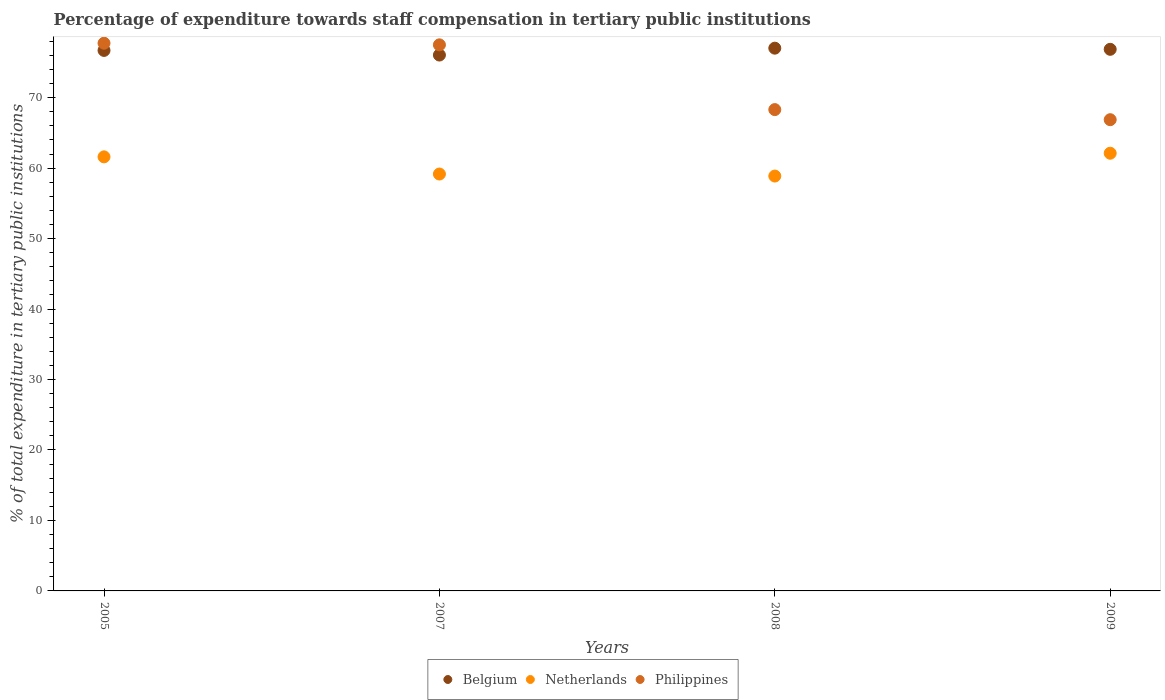How many different coloured dotlines are there?
Make the answer very short. 3. What is the percentage of expenditure towards staff compensation in Philippines in 2009?
Ensure brevity in your answer.  66.88. Across all years, what is the maximum percentage of expenditure towards staff compensation in Philippines?
Your answer should be very brief. 77.73. Across all years, what is the minimum percentage of expenditure towards staff compensation in Philippines?
Give a very brief answer. 66.88. What is the total percentage of expenditure towards staff compensation in Philippines in the graph?
Make the answer very short. 290.41. What is the difference between the percentage of expenditure towards staff compensation in Philippines in 2007 and that in 2008?
Give a very brief answer. 9.19. What is the difference between the percentage of expenditure towards staff compensation in Philippines in 2008 and the percentage of expenditure towards staff compensation in Belgium in 2007?
Your response must be concise. -7.74. What is the average percentage of expenditure towards staff compensation in Belgium per year?
Your answer should be compact. 76.66. In the year 2005, what is the difference between the percentage of expenditure towards staff compensation in Netherlands and percentage of expenditure towards staff compensation in Belgium?
Your response must be concise. -15.1. What is the ratio of the percentage of expenditure towards staff compensation in Philippines in 2008 to that in 2009?
Provide a short and direct response. 1.02. Is the percentage of expenditure towards staff compensation in Belgium in 2005 less than that in 2009?
Your response must be concise. Yes. What is the difference between the highest and the second highest percentage of expenditure towards staff compensation in Netherlands?
Make the answer very short. 0.51. What is the difference between the highest and the lowest percentage of expenditure towards staff compensation in Netherlands?
Keep it short and to the point. 3.24. In how many years, is the percentage of expenditure towards staff compensation in Philippines greater than the average percentage of expenditure towards staff compensation in Philippines taken over all years?
Your answer should be very brief. 2. Is the sum of the percentage of expenditure towards staff compensation in Belgium in 2008 and 2009 greater than the maximum percentage of expenditure towards staff compensation in Philippines across all years?
Keep it short and to the point. Yes. Is it the case that in every year, the sum of the percentage of expenditure towards staff compensation in Netherlands and percentage of expenditure towards staff compensation in Philippines  is greater than the percentage of expenditure towards staff compensation in Belgium?
Your answer should be very brief. Yes. Is the percentage of expenditure towards staff compensation in Belgium strictly less than the percentage of expenditure towards staff compensation in Netherlands over the years?
Your response must be concise. No. How many years are there in the graph?
Provide a short and direct response. 4. Are the values on the major ticks of Y-axis written in scientific E-notation?
Keep it short and to the point. No. Where does the legend appear in the graph?
Offer a very short reply. Bottom center. How are the legend labels stacked?
Offer a very short reply. Horizontal. What is the title of the graph?
Give a very brief answer. Percentage of expenditure towards staff compensation in tertiary public institutions. What is the label or title of the X-axis?
Offer a very short reply. Years. What is the label or title of the Y-axis?
Offer a very short reply. % of total expenditure in tertiary public institutions. What is the % of total expenditure in tertiary public institutions of Belgium in 2005?
Make the answer very short. 76.71. What is the % of total expenditure in tertiary public institutions of Netherlands in 2005?
Ensure brevity in your answer.  61.6. What is the % of total expenditure in tertiary public institutions of Philippines in 2005?
Offer a terse response. 77.73. What is the % of total expenditure in tertiary public institutions in Belgium in 2007?
Your response must be concise. 76.05. What is the % of total expenditure in tertiary public institutions in Netherlands in 2007?
Your answer should be very brief. 59.17. What is the % of total expenditure in tertiary public institutions in Philippines in 2007?
Your answer should be very brief. 77.5. What is the % of total expenditure in tertiary public institutions of Belgium in 2008?
Offer a very short reply. 77.03. What is the % of total expenditure in tertiary public institutions in Netherlands in 2008?
Your answer should be very brief. 58.88. What is the % of total expenditure in tertiary public institutions in Philippines in 2008?
Your answer should be very brief. 68.31. What is the % of total expenditure in tertiary public institutions of Belgium in 2009?
Your answer should be very brief. 76.86. What is the % of total expenditure in tertiary public institutions of Netherlands in 2009?
Offer a very short reply. 62.12. What is the % of total expenditure in tertiary public institutions in Philippines in 2009?
Provide a succinct answer. 66.88. Across all years, what is the maximum % of total expenditure in tertiary public institutions of Belgium?
Give a very brief answer. 77.03. Across all years, what is the maximum % of total expenditure in tertiary public institutions in Netherlands?
Your response must be concise. 62.12. Across all years, what is the maximum % of total expenditure in tertiary public institutions of Philippines?
Offer a very short reply. 77.73. Across all years, what is the minimum % of total expenditure in tertiary public institutions in Belgium?
Ensure brevity in your answer.  76.05. Across all years, what is the minimum % of total expenditure in tertiary public institutions in Netherlands?
Your response must be concise. 58.88. Across all years, what is the minimum % of total expenditure in tertiary public institutions in Philippines?
Your response must be concise. 66.88. What is the total % of total expenditure in tertiary public institutions in Belgium in the graph?
Make the answer very short. 306.64. What is the total % of total expenditure in tertiary public institutions of Netherlands in the graph?
Keep it short and to the point. 241.76. What is the total % of total expenditure in tertiary public institutions of Philippines in the graph?
Keep it short and to the point. 290.41. What is the difference between the % of total expenditure in tertiary public institutions in Belgium in 2005 and that in 2007?
Your response must be concise. 0.66. What is the difference between the % of total expenditure in tertiary public institutions of Netherlands in 2005 and that in 2007?
Offer a terse response. 2.44. What is the difference between the % of total expenditure in tertiary public institutions in Philippines in 2005 and that in 2007?
Ensure brevity in your answer.  0.23. What is the difference between the % of total expenditure in tertiary public institutions in Belgium in 2005 and that in 2008?
Your response must be concise. -0.32. What is the difference between the % of total expenditure in tertiary public institutions of Netherlands in 2005 and that in 2008?
Keep it short and to the point. 2.73. What is the difference between the % of total expenditure in tertiary public institutions in Philippines in 2005 and that in 2008?
Provide a short and direct response. 9.42. What is the difference between the % of total expenditure in tertiary public institutions in Belgium in 2005 and that in 2009?
Provide a succinct answer. -0.16. What is the difference between the % of total expenditure in tertiary public institutions in Netherlands in 2005 and that in 2009?
Offer a very short reply. -0.51. What is the difference between the % of total expenditure in tertiary public institutions of Philippines in 2005 and that in 2009?
Your response must be concise. 10.85. What is the difference between the % of total expenditure in tertiary public institutions in Belgium in 2007 and that in 2008?
Keep it short and to the point. -0.98. What is the difference between the % of total expenditure in tertiary public institutions of Netherlands in 2007 and that in 2008?
Make the answer very short. 0.29. What is the difference between the % of total expenditure in tertiary public institutions of Philippines in 2007 and that in 2008?
Give a very brief answer. 9.19. What is the difference between the % of total expenditure in tertiary public institutions in Belgium in 2007 and that in 2009?
Ensure brevity in your answer.  -0.81. What is the difference between the % of total expenditure in tertiary public institutions of Netherlands in 2007 and that in 2009?
Keep it short and to the point. -2.95. What is the difference between the % of total expenditure in tertiary public institutions in Philippines in 2007 and that in 2009?
Give a very brief answer. 10.62. What is the difference between the % of total expenditure in tertiary public institutions of Belgium in 2008 and that in 2009?
Make the answer very short. 0.16. What is the difference between the % of total expenditure in tertiary public institutions in Netherlands in 2008 and that in 2009?
Make the answer very short. -3.24. What is the difference between the % of total expenditure in tertiary public institutions of Philippines in 2008 and that in 2009?
Provide a succinct answer. 1.43. What is the difference between the % of total expenditure in tertiary public institutions in Belgium in 2005 and the % of total expenditure in tertiary public institutions in Netherlands in 2007?
Your response must be concise. 17.54. What is the difference between the % of total expenditure in tertiary public institutions in Belgium in 2005 and the % of total expenditure in tertiary public institutions in Philippines in 2007?
Your answer should be compact. -0.79. What is the difference between the % of total expenditure in tertiary public institutions in Netherlands in 2005 and the % of total expenditure in tertiary public institutions in Philippines in 2007?
Ensure brevity in your answer.  -15.9. What is the difference between the % of total expenditure in tertiary public institutions of Belgium in 2005 and the % of total expenditure in tertiary public institutions of Netherlands in 2008?
Provide a short and direct response. 17.83. What is the difference between the % of total expenditure in tertiary public institutions in Belgium in 2005 and the % of total expenditure in tertiary public institutions in Philippines in 2008?
Your answer should be compact. 8.4. What is the difference between the % of total expenditure in tertiary public institutions in Netherlands in 2005 and the % of total expenditure in tertiary public institutions in Philippines in 2008?
Provide a succinct answer. -6.7. What is the difference between the % of total expenditure in tertiary public institutions of Belgium in 2005 and the % of total expenditure in tertiary public institutions of Netherlands in 2009?
Ensure brevity in your answer.  14.59. What is the difference between the % of total expenditure in tertiary public institutions of Belgium in 2005 and the % of total expenditure in tertiary public institutions of Philippines in 2009?
Your answer should be compact. 9.83. What is the difference between the % of total expenditure in tertiary public institutions of Netherlands in 2005 and the % of total expenditure in tertiary public institutions of Philippines in 2009?
Give a very brief answer. -5.27. What is the difference between the % of total expenditure in tertiary public institutions of Belgium in 2007 and the % of total expenditure in tertiary public institutions of Netherlands in 2008?
Your response must be concise. 17.17. What is the difference between the % of total expenditure in tertiary public institutions of Belgium in 2007 and the % of total expenditure in tertiary public institutions of Philippines in 2008?
Give a very brief answer. 7.74. What is the difference between the % of total expenditure in tertiary public institutions of Netherlands in 2007 and the % of total expenditure in tertiary public institutions of Philippines in 2008?
Ensure brevity in your answer.  -9.14. What is the difference between the % of total expenditure in tertiary public institutions in Belgium in 2007 and the % of total expenditure in tertiary public institutions in Netherlands in 2009?
Keep it short and to the point. 13.93. What is the difference between the % of total expenditure in tertiary public institutions in Belgium in 2007 and the % of total expenditure in tertiary public institutions in Philippines in 2009?
Keep it short and to the point. 9.17. What is the difference between the % of total expenditure in tertiary public institutions in Netherlands in 2007 and the % of total expenditure in tertiary public institutions in Philippines in 2009?
Ensure brevity in your answer.  -7.71. What is the difference between the % of total expenditure in tertiary public institutions of Belgium in 2008 and the % of total expenditure in tertiary public institutions of Netherlands in 2009?
Your answer should be very brief. 14.91. What is the difference between the % of total expenditure in tertiary public institutions in Belgium in 2008 and the % of total expenditure in tertiary public institutions in Philippines in 2009?
Your response must be concise. 10.15. What is the difference between the % of total expenditure in tertiary public institutions of Netherlands in 2008 and the % of total expenditure in tertiary public institutions of Philippines in 2009?
Keep it short and to the point. -8. What is the average % of total expenditure in tertiary public institutions of Belgium per year?
Offer a terse response. 76.66. What is the average % of total expenditure in tertiary public institutions in Netherlands per year?
Keep it short and to the point. 60.44. What is the average % of total expenditure in tertiary public institutions of Philippines per year?
Offer a terse response. 72.6. In the year 2005, what is the difference between the % of total expenditure in tertiary public institutions of Belgium and % of total expenditure in tertiary public institutions of Netherlands?
Your answer should be compact. 15.1. In the year 2005, what is the difference between the % of total expenditure in tertiary public institutions of Belgium and % of total expenditure in tertiary public institutions of Philippines?
Your answer should be compact. -1.02. In the year 2005, what is the difference between the % of total expenditure in tertiary public institutions of Netherlands and % of total expenditure in tertiary public institutions of Philippines?
Provide a succinct answer. -16.13. In the year 2007, what is the difference between the % of total expenditure in tertiary public institutions in Belgium and % of total expenditure in tertiary public institutions in Netherlands?
Give a very brief answer. 16.88. In the year 2007, what is the difference between the % of total expenditure in tertiary public institutions of Belgium and % of total expenditure in tertiary public institutions of Philippines?
Provide a short and direct response. -1.45. In the year 2007, what is the difference between the % of total expenditure in tertiary public institutions in Netherlands and % of total expenditure in tertiary public institutions in Philippines?
Keep it short and to the point. -18.33. In the year 2008, what is the difference between the % of total expenditure in tertiary public institutions of Belgium and % of total expenditure in tertiary public institutions of Netherlands?
Provide a short and direct response. 18.15. In the year 2008, what is the difference between the % of total expenditure in tertiary public institutions in Belgium and % of total expenditure in tertiary public institutions in Philippines?
Offer a terse response. 8.72. In the year 2008, what is the difference between the % of total expenditure in tertiary public institutions of Netherlands and % of total expenditure in tertiary public institutions of Philippines?
Offer a very short reply. -9.43. In the year 2009, what is the difference between the % of total expenditure in tertiary public institutions of Belgium and % of total expenditure in tertiary public institutions of Netherlands?
Keep it short and to the point. 14.75. In the year 2009, what is the difference between the % of total expenditure in tertiary public institutions in Belgium and % of total expenditure in tertiary public institutions in Philippines?
Ensure brevity in your answer.  9.99. In the year 2009, what is the difference between the % of total expenditure in tertiary public institutions of Netherlands and % of total expenditure in tertiary public institutions of Philippines?
Give a very brief answer. -4.76. What is the ratio of the % of total expenditure in tertiary public institutions of Belgium in 2005 to that in 2007?
Keep it short and to the point. 1.01. What is the ratio of the % of total expenditure in tertiary public institutions in Netherlands in 2005 to that in 2007?
Provide a short and direct response. 1.04. What is the ratio of the % of total expenditure in tertiary public institutions of Philippines in 2005 to that in 2007?
Offer a very short reply. 1. What is the ratio of the % of total expenditure in tertiary public institutions of Belgium in 2005 to that in 2008?
Your answer should be very brief. 1. What is the ratio of the % of total expenditure in tertiary public institutions in Netherlands in 2005 to that in 2008?
Offer a terse response. 1.05. What is the ratio of the % of total expenditure in tertiary public institutions in Philippines in 2005 to that in 2008?
Your answer should be compact. 1.14. What is the ratio of the % of total expenditure in tertiary public institutions of Netherlands in 2005 to that in 2009?
Give a very brief answer. 0.99. What is the ratio of the % of total expenditure in tertiary public institutions of Philippines in 2005 to that in 2009?
Your response must be concise. 1.16. What is the ratio of the % of total expenditure in tertiary public institutions in Belgium in 2007 to that in 2008?
Offer a very short reply. 0.99. What is the ratio of the % of total expenditure in tertiary public institutions in Netherlands in 2007 to that in 2008?
Give a very brief answer. 1. What is the ratio of the % of total expenditure in tertiary public institutions of Philippines in 2007 to that in 2008?
Your answer should be very brief. 1.13. What is the ratio of the % of total expenditure in tertiary public institutions of Belgium in 2007 to that in 2009?
Your response must be concise. 0.99. What is the ratio of the % of total expenditure in tertiary public institutions in Netherlands in 2007 to that in 2009?
Offer a terse response. 0.95. What is the ratio of the % of total expenditure in tertiary public institutions of Philippines in 2007 to that in 2009?
Provide a short and direct response. 1.16. What is the ratio of the % of total expenditure in tertiary public institutions of Belgium in 2008 to that in 2009?
Provide a succinct answer. 1. What is the ratio of the % of total expenditure in tertiary public institutions in Netherlands in 2008 to that in 2009?
Your answer should be very brief. 0.95. What is the ratio of the % of total expenditure in tertiary public institutions of Philippines in 2008 to that in 2009?
Make the answer very short. 1.02. What is the difference between the highest and the second highest % of total expenditure in tertiary public institutions of Belgium?
Offer a terse response. 0.16. What is the difference between the highest and the second highest % of total expenditure in tertiary public institutions of Netherlands?
Offer a terse response. 0.51. What is the difference between the highest and the second highest % of total expenditure in tertiary public institutions in Philippines?
Keep it short and to the point. 0.23. What is the difference between the highest and the lowest % of total expenditure in tertiary public institutions of Belgium?
Your answer should be compact. 0.98. What is the difference between the highest and the lowest % of total expenditure in tertiary public institutions in Netherlands?
Provide a succinct answer. 3.24. What is the difference between the highest and the lowest % of total expenditure in tertiary public institutions of Philippines?
Provide a short and direct response. 10.85. 